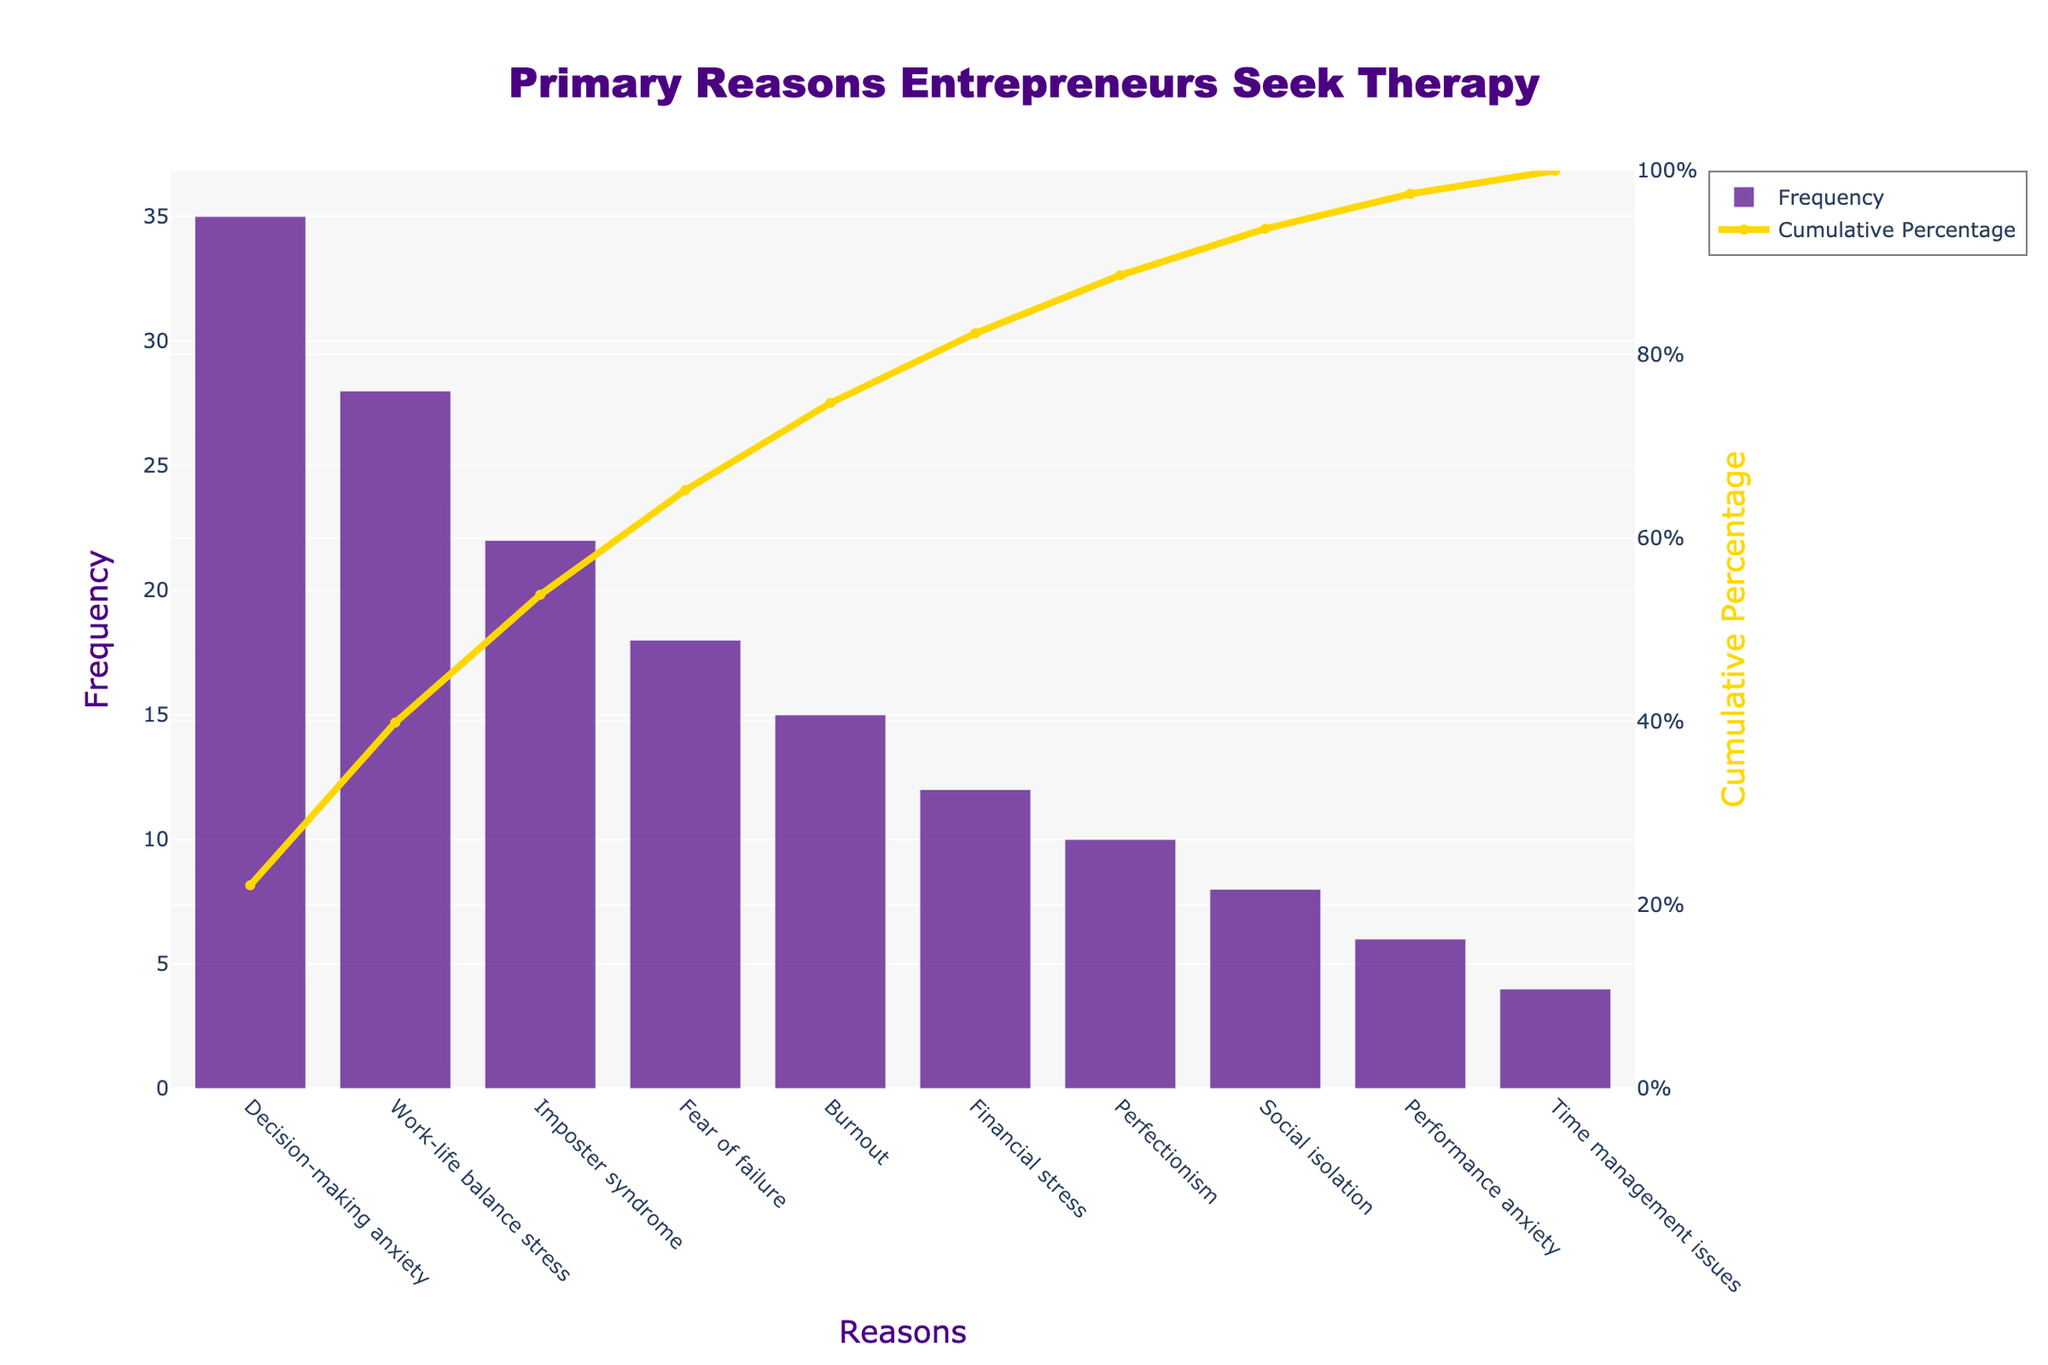What is the title of the chart? The title is a straightforward element of the figure, located at the top center. Reading it helps identify the overall topic the chart covers.
Answer: Primary Reasons Entrepreneurs Seek Therapy Which reason has the highest frequency? Observe the tallest bar in the bar chart which corresponds to the reason with the highest frequency.
Answer: Decision-making anxiety What color is used for the bars representing the frequency? Look at the color of the bars in the bar chart.
Answer: Indigo How many reasons are listed in the chart? Count the number of bars on the x-axis, each representing a reason.
Answer: 10 What is the cumulative percentage reached by "Imposter syndrome"? Follow the cumulative percentage line to the point corresponding to "Imposter syndrome" and read the value on the right y-axis.
Answer: 60% What is the combined frequency of "Work-life balance stress" and "Fear of failure"? Retrieve the frequencies from the bars for "Work-life balance stress" (28) and "Fear of failure" (18), and add them together: 28 + 18 = 46.
Answer: 46 Which reasons have a frequency greater than 20? Identify the bars with heights associated with frequencies greater than 20; these correspond to the reasons above that threshold.
Answer: Decision-making anxiety, Work-life balance stress, Imposter syndrome What is the cumulative percentage for the top three reasons? Sum the frequencies of the top three reasons (35 for Decision-making anxiety, 28 for Work-life balance stress, and 22 for Imposter syndrome) and divide by the total frequency sum then multiply by 100: (35 + 28 + 22) / 158 * 100 = 53.8%; this matches the visual cumulative line's value after three reasons.
Answer: 53.8% Which reason has a lower frequency: "Burnout" or "Perfectionism"? Compare the bar heights for "Burnout" (15) and "Perfectionism" (10).
Answer: Perfectionism 